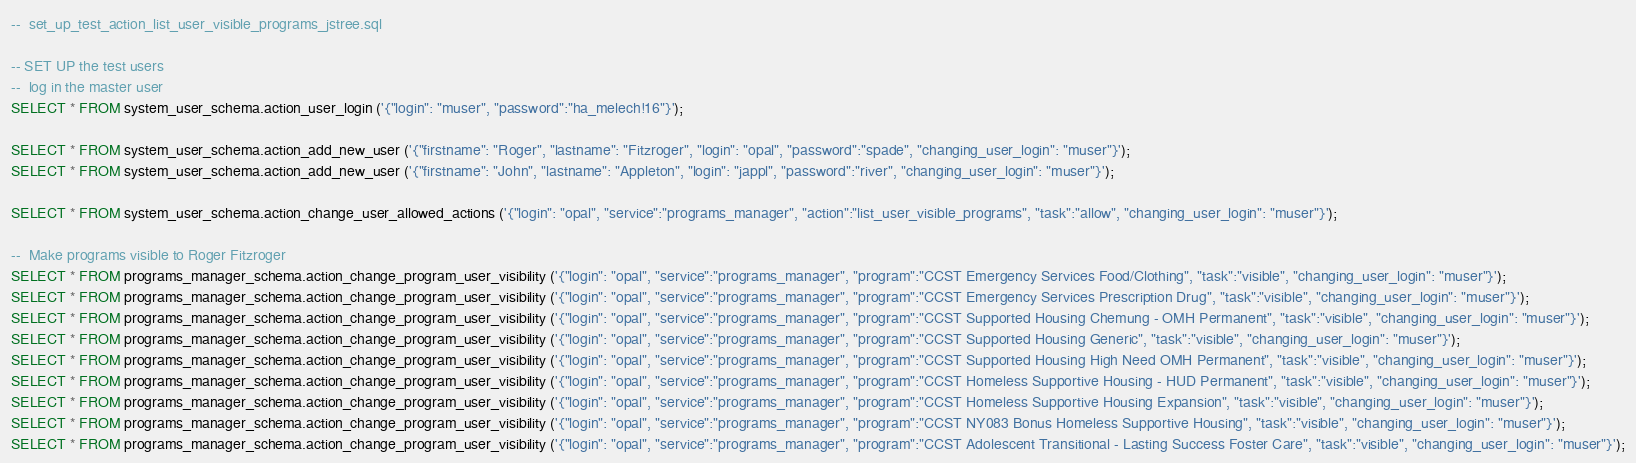<code> <loc_0><loc_0><loc_500><loc_500><_SQL_>--	set_up_test_action_list_user_visible_programs_jstree.sql

-- SET UP the test users
--	log in the master user
SELECT * FROM system_user_schema.action_user_login ('{"login": "muser", "password":"ha_melech!16"}');

SELECT * FROM system_user_schema.action_add_new_user ('{"firstname": "Roger", "lastname": "Fitzroger", "login": "opal", "password":"spade", "changing_user_login": "muser"}');
SELECT * FROM system_user_schema.action_add_new_user ('{"firstname": "John", "lastname": "Appleton", "login": "jappl", "password":"river", "changing_user_login": "muser"}');

SELECT * FROM system_user_schema.action_change_user_allowed_actions ('{"login": "opal", "service":"programs_manager", "action":"list_user_visible_programs", "task":"allow", "changing_user_login": "muser"}');

--	Make programs visible to Roger Fitzroger
SELECT * FROM programs_manager_schema.action_change_program_user_visibility ('{"login": "opal", "service":"programs_manager", "program":"CCST Emergency Services Food/Clothing", "task":"visible", "changing_user_login": "muser"}');
SELECT * FROM programs_manager_schema.action_change_program_user_visibility ('{"login": "opal", "service":"programs_manager", "program":"CCST Emergency Services Prescription Drug", "task":"visible", "changing_user_login": "muser"}');
SELECT * FROM programs_manager_schema.action_change_program_user_visibility ('{"login": "opal", "service":"programs_manager", "program":"CCST Supported Housing Chemung - OMH Permanent", "task":"visible", "changing_user_login": "muser"}');
SELECT * FROM programs_manager_schema.action_change_program_user_visibility ('{"login": "opal", "service":"programs_manager", "program":"CCST Supported Housing Generic", "task":"visible", "changing_user_login": "muser"}');
SELECT * FROM programs_manager_schema.action_change_program_user_visibility ('{"login": "opal", "service":"programs_manager", "program":"CCST Supported Housing High Need OMH Permanent", "task":"visible", "changing_user_login": "muser"}');
SELECT * FROM programs_manager_schema.action_change_program_user_visibility ('{"login": "opal", "service":"programs_manager", "program":"CCST Homeless Supportive Housing - HUD Permanent", "task":"visible", "changing_user_login": "muser"}');
SELECT * FROM programs_manager_schema.action_change_program_user_visibility ('{"login": "opal", "service":"programs_manager", "program":"CCST Homeless Supportive Housing Expansion", "task":"visible", "changing_user_login": "muser"}');
SELECT * FROM programs_manager_schema.action_change_program_user_visibility ('{"login": "opal", "service":"programs_manager", "program":"CCST NY083 Bonus Homeless Supportive Housing", "task":"visible", "changing_user_login": "muser"}');
SELECT * FROM programs_manager_schema.action_change_program_user_visibility ('{"login": "opal", "service":"programs_manager", "program":"CCST Adolescent Transitional - Lasting Success Foster Care", "task":"visible", "changing_user_login": "muser"}');</code> 